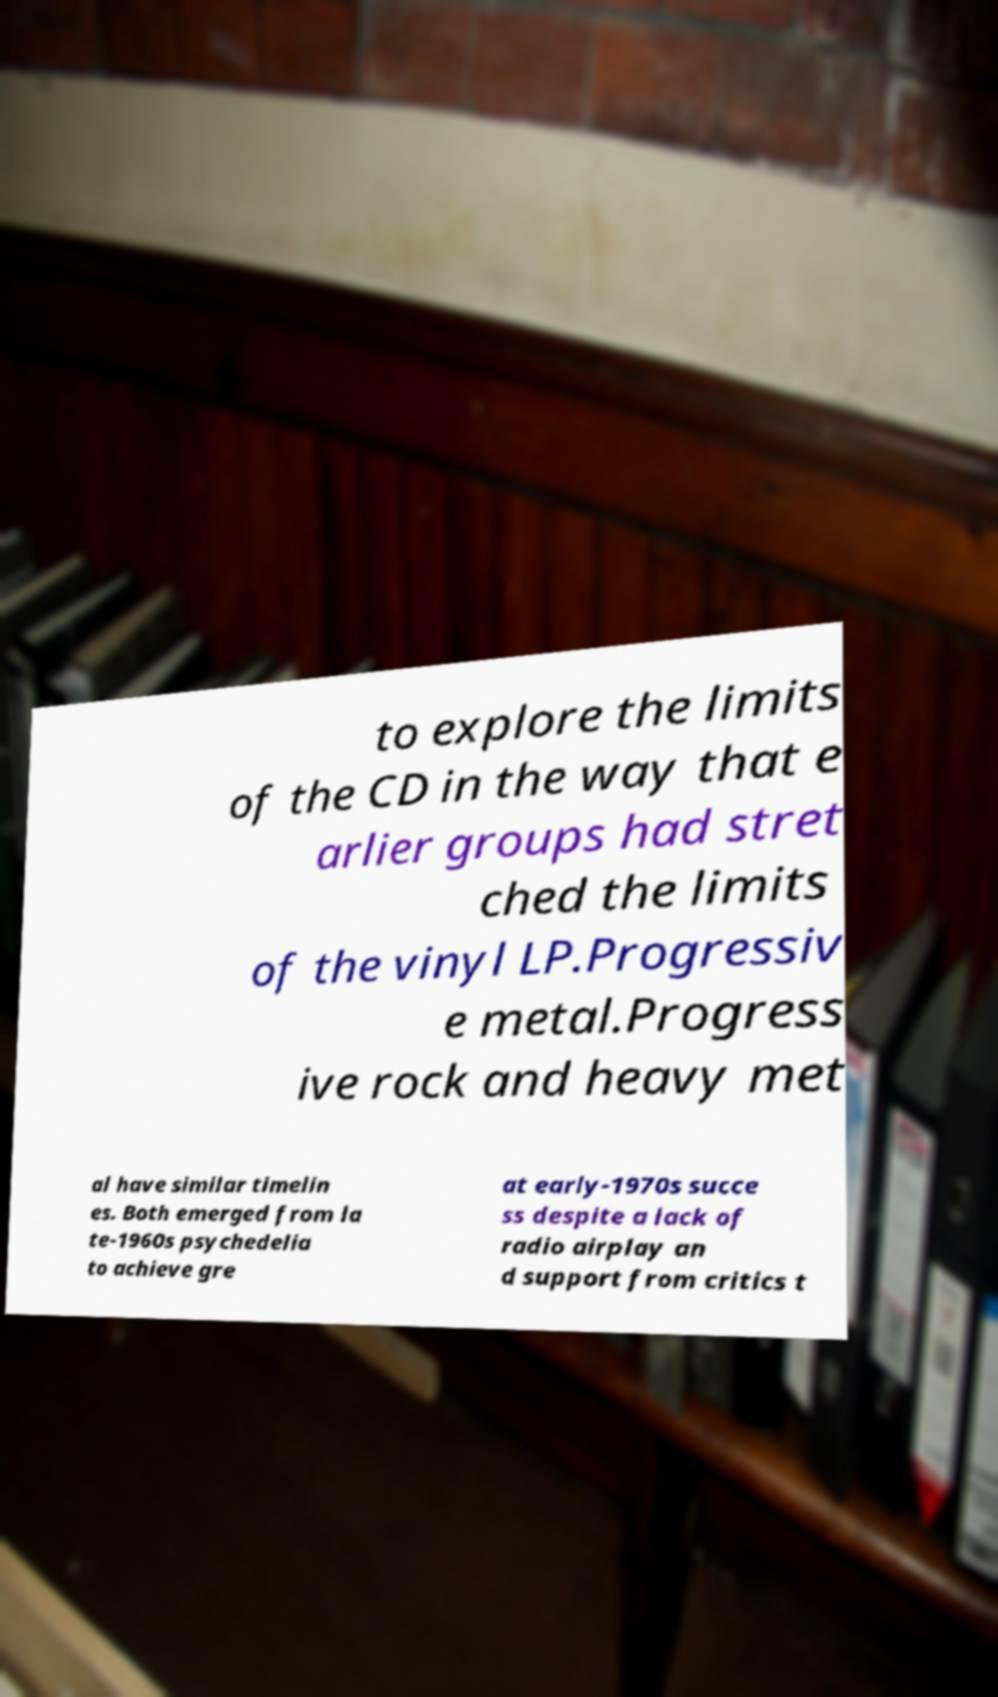What messages or text are displayed in this image? I need them in a readable, typed format. to explore the limits of the CD in the way that e arlier groups had stret ched the limits of the vinyl LP.Progressiv e metal.Progress ive rock and heavy met al have similar timelin es. Both emerged from la te-1960s psychedelia to achieve gre at early-1970s succe ss despite a lack of radio airplay an d support from critics t 